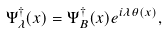<formula> <loc_0><loc_0><loc_500><loc_500>\Psi ^ { \dagger } _ { \lambda } ( x ) = \Psi ^ { \dagger } _ { B } ( x ) e ^ { i \lambda \theta ( x ) } ,</formula> 